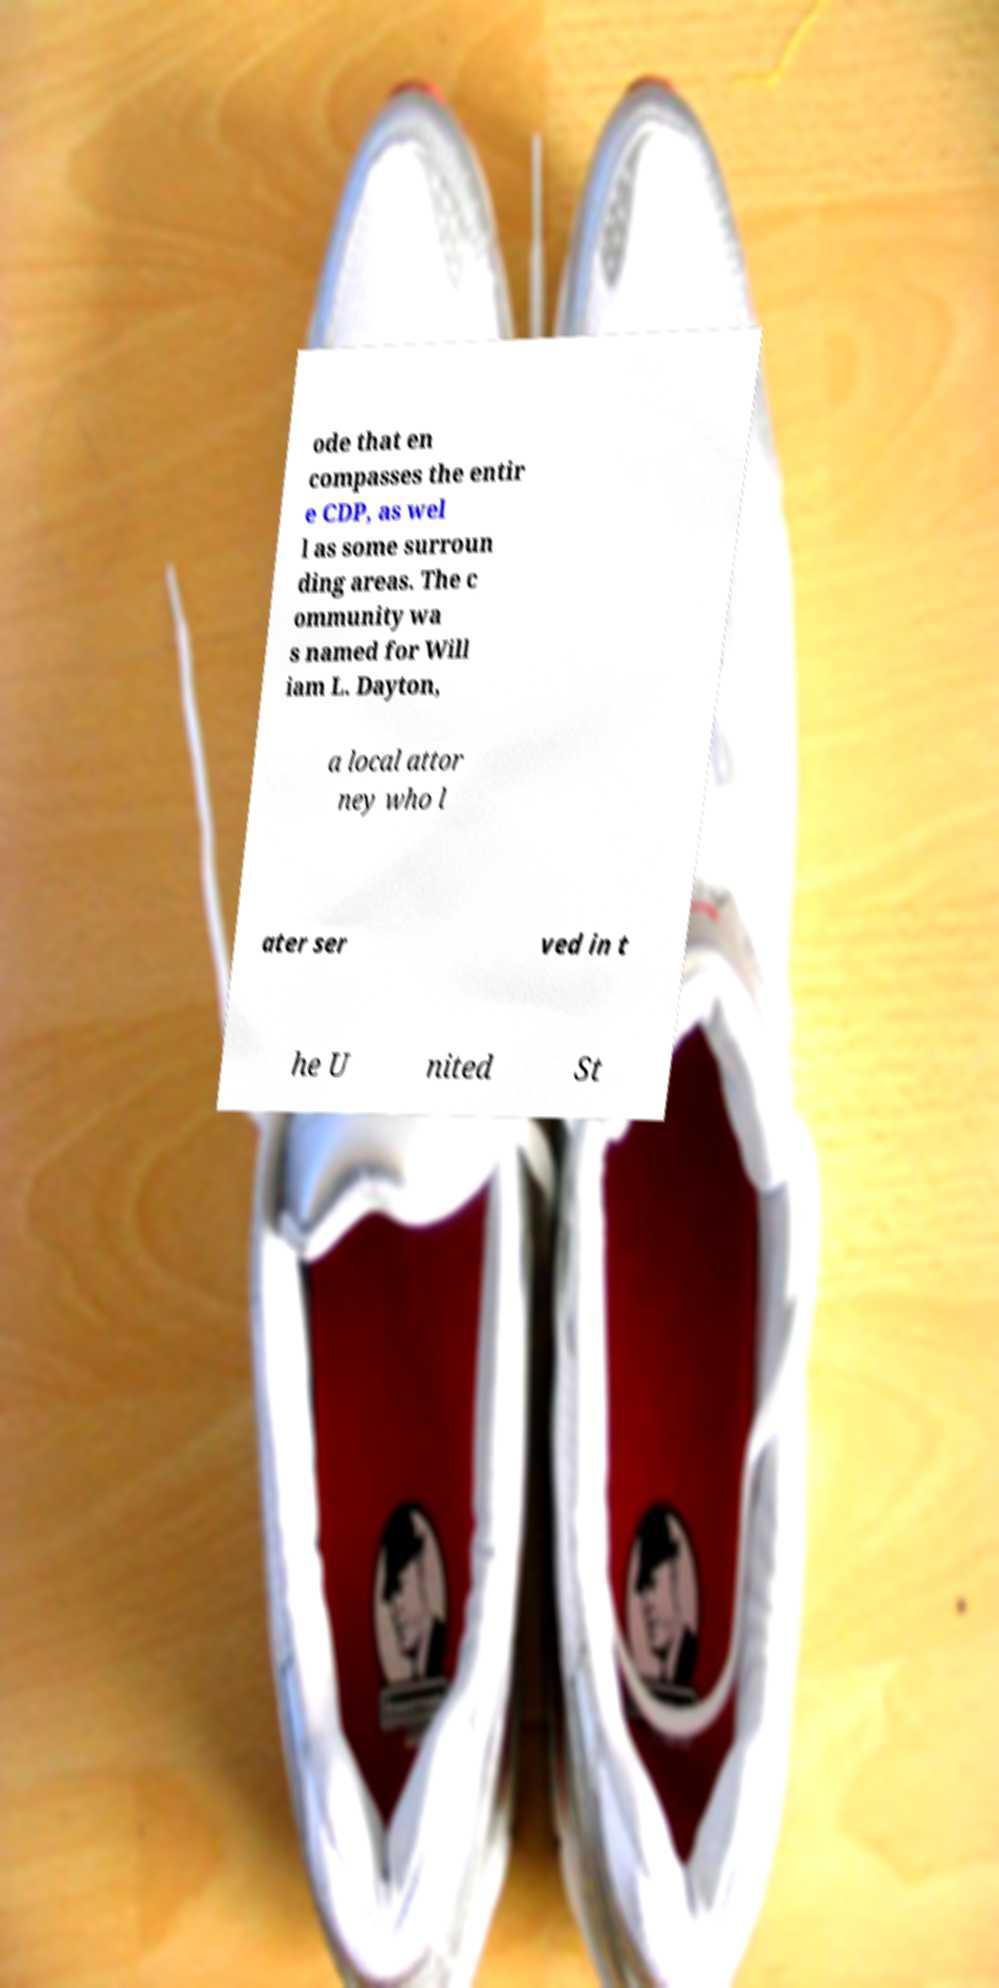What messages or text are displayed in this image? I need them in a readable, typed format. ode that en compasses the entir e CDP, as wel l as some surroun ding areas. The c ommunity wa s named for Will iam L. Dayton, a local attor ney who l ater ser ved in t he U nited St 